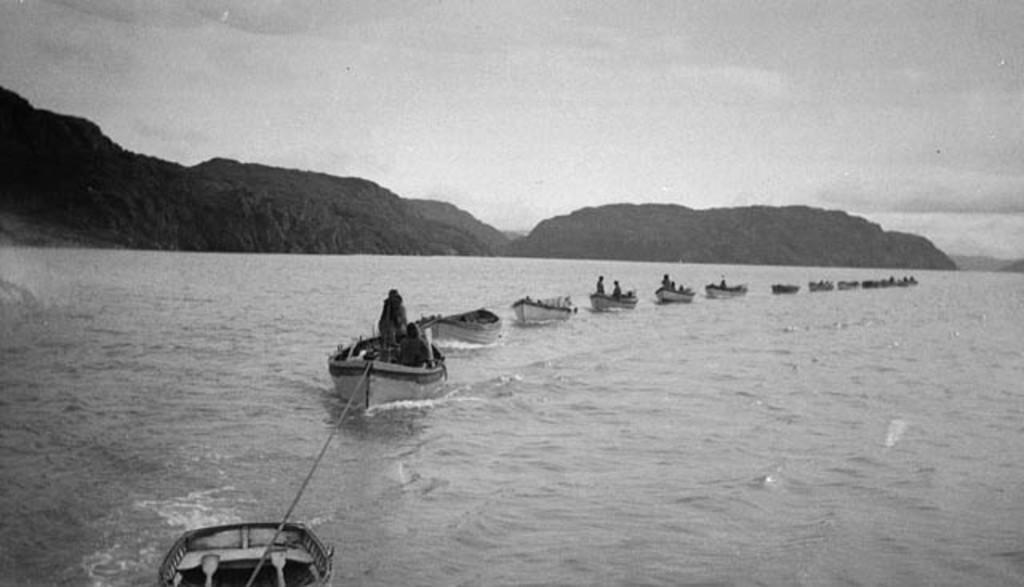Describe this image in one or two sentences. This is an old black and white image. I can see few people in the boats. These boots are moving on the water. I can see the hills. This is the sky. 